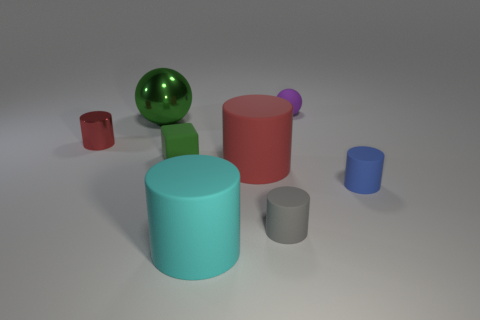How many other objects are the same shape as the big metal object?
Give a very brief answer. 1. What material is the small gray thing?
Give a very brief answer. Rubber. Does the small rubber cube have the same color as the object left of the green ball?
Your answer should be very brief. No. What number of cubes are small gray things or shiny things?
Ensure brevity in your answer.  0. There is a cylinder left of the cyan rubber object; what color is it?
Your answer should be compact. Red. There is a small rubber object that is the same color as the big ball; what is its shape?
Your answer should be compact. Cube. What number of cylinders are the same size as the green ball?
Give a very brief answer. 2. Is the shape of the large thing behind the big red thing the same as the small matte thing that is behind the tiny red shiny cylinder?
Your answer should be very brief. Yes. There is a large object that is behind the large matte cylinder behind the tiny rubber cylinder right of the tiny gray cylinder; what is its material?
Your answer should be compact. Metal. The purple thing that is the same size as the gray cylinder is what shape?
Your answer should be compact. Sphere. 